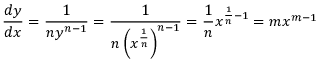Convert formula to latex. <formula><loc_0><loc_0><loc_500><loc_500>{ \frac { d y } { d x } } = { \frac { 1 } { n y ^ { n - 1 } } } = { \frac { 1 } { n \left ( x ^ { \frac { 1 } { n } } \right ) ^ { n - 1 } } } = { \frac { 1 } { n } } x ^ { { \frac { 1 } { n } } - 1 } = m x ^ { m - 1 }</formula> 